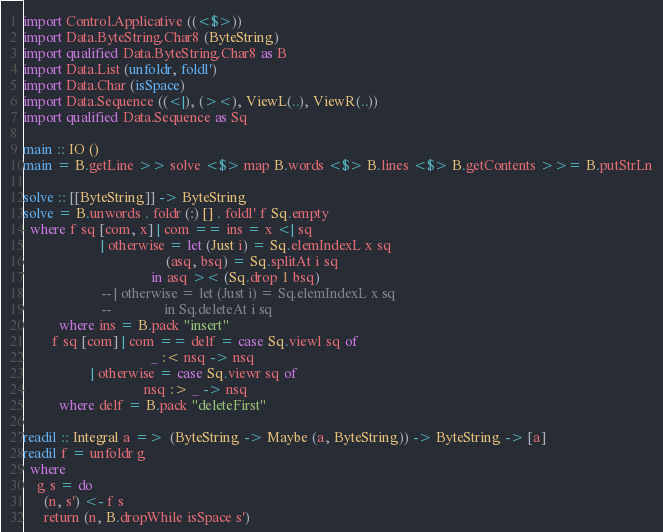<code> <loc_0><loc_0><loc_500><loc_500><_Haskell_>import Control.Applicative ((<$>))
import Data.ByteString.Char8 (ByteString)
import qualified Data.ByteString.Char8 as B
import Data.List (unfoldr, foldl')
import Data.Char (isSpace)
import Data.Sequence ((<|), (><), ViewL(..), ViewR(..))
import qualified Data.Sequence as Sq

main :: IO ()
main = B.getLine >> solve <$> map B.words <$> B.lines <$> B.getContents >>= B.putStrLn

solve :: [[ByteString]] -> ByteString
solve = B.unwords . foldr (:) [] . foldl' f Sq.empty
  where f sq [com, x] | com == ins = x <| sq
                      | otherwise = let (Just i) = Sq.elemIndexL x sq
                                        (asq, bsq) = Sq.splitAt i sq
                                    in asq >< (Sq.drop 1 bsq)
                      -- | otherwise = let (Just i) = Sq.elemIndexL x sq
                      --               in Sq.deleteAt i sq
          where ins = B.pack "insert"
        f sq [com] | com == delf = case Sq.viewl sq of
                                    _ :< nsq -> nsq
                   | otherwise = case Sq.viewr sq of
                                  nsq :> _ -> nsq
          where delf = B.pack "deleteFirst"

readil :: Integral a =>  (ByteString -> Maybe (a, ByteString)) -> ByteString -> [a]
readil f = unfoldr g
  where
    g s = do
      (n, s') <- f s
      return (n, B.dropWhile isSpace s')

</code> 